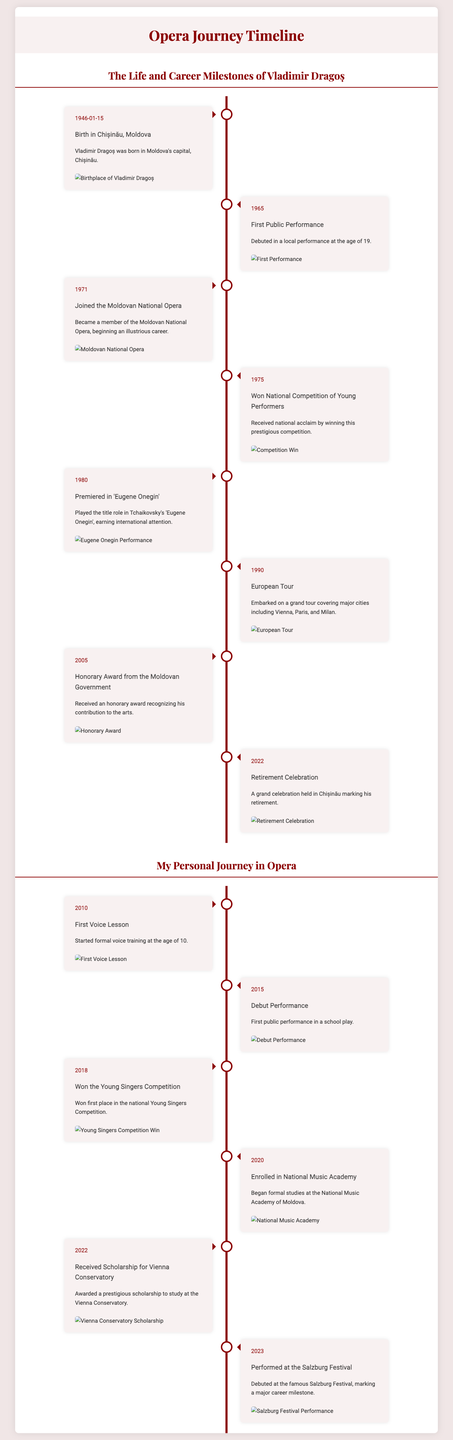What year was Vladimir Dragoș born? The document states that Vladimir Dragoș was born on January 15, 1946.
Answer: 1946 What was the title of the opera in which Dragoș premiered in 1980? The 1980 event mentions that he played the title role in Tchaikovsky's 'Eugene Onegin'.
Answer: Eugene Onegin What significant award did Dragoș receive in 2005? In 2005, he received an honorary award recognizing his contribution to the arts.
Answer: Honorary Award When did you perform at the Salzburg Festival? The timeline indicates that you performed at the Salzburg Festival in 2023.
Answer: 2023 What milestone in your personal opera journey occurred in 2018? In 2018, you won first place in the national Young Singers Competition.
Answer: Young Singers Competition How old was Dragoș during his first public performance? The document notes that he debuted at the age of 19, which indicates he was born in 1946.
Answer: 19 What key event is noted for Dragoș in 1990? Dragoș embarked on a grand European tour in 1990.
Answer: European Tour What did you achieve in 2022 related to your education? In 2022, you received a prestigious scholarship to study at the Vienna Conservatory.
Answer: Scholarship What does the left section of the timeline primarily detail? The left section primarily details milestones from Vladimir Dragoș's life and career.
Answer: Dragoș's milestones 